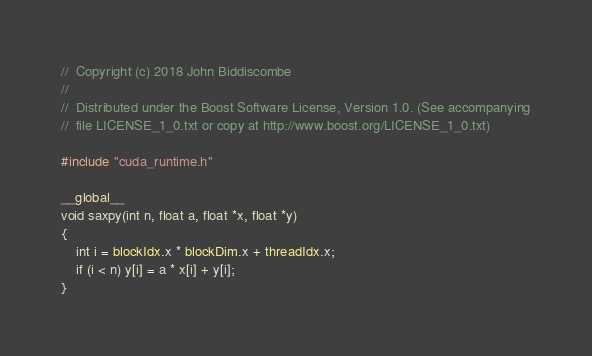<code> <loc_0><loc_0><loc_500><loc_500><_Cuda_>//  Copyright (c) 2018 John Biddiscombe
//
//  Distributed under the Boost Software License, Version 1.0. (See accompanying
//  file LICENSE_1_0.txt or copy at http://www.boost.org/LICENSE_1_0.txt)

#include "cuda_runtime.h"

__global__
void saxpy(int n, float a, float *x, float *y)
{
    int i = blockIdx.x * blockDim.x + threadIdx.x;
    if (i < n) y[i] = a * x[i] + y[i];
}

</code> 